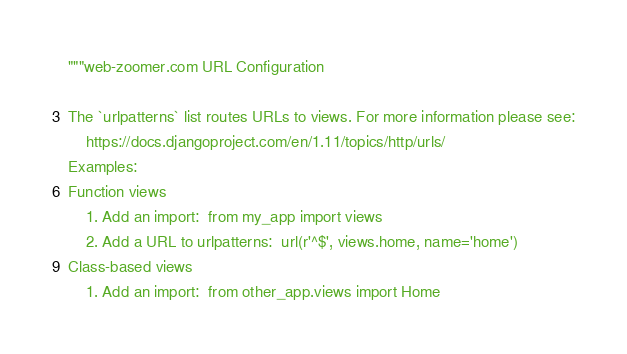Convert code to text. <code><loc_0><loc_0><loc_500><loc_500><_Python_>"""web-zoomer.com URL Configuration

The `urlpatterns` list routes URLs to views. For more information please see:
    https://docs.djangoproject.com/en/1.11/topics/http/urls/
Examples:
Function views
    1. Add an import:  from my_app import views
    2. Add a URL to urlpatterns:  url(r'^$', views.home, name='home')
Class-based views
    1. Add an import:  from other_app.views import Home</code> 